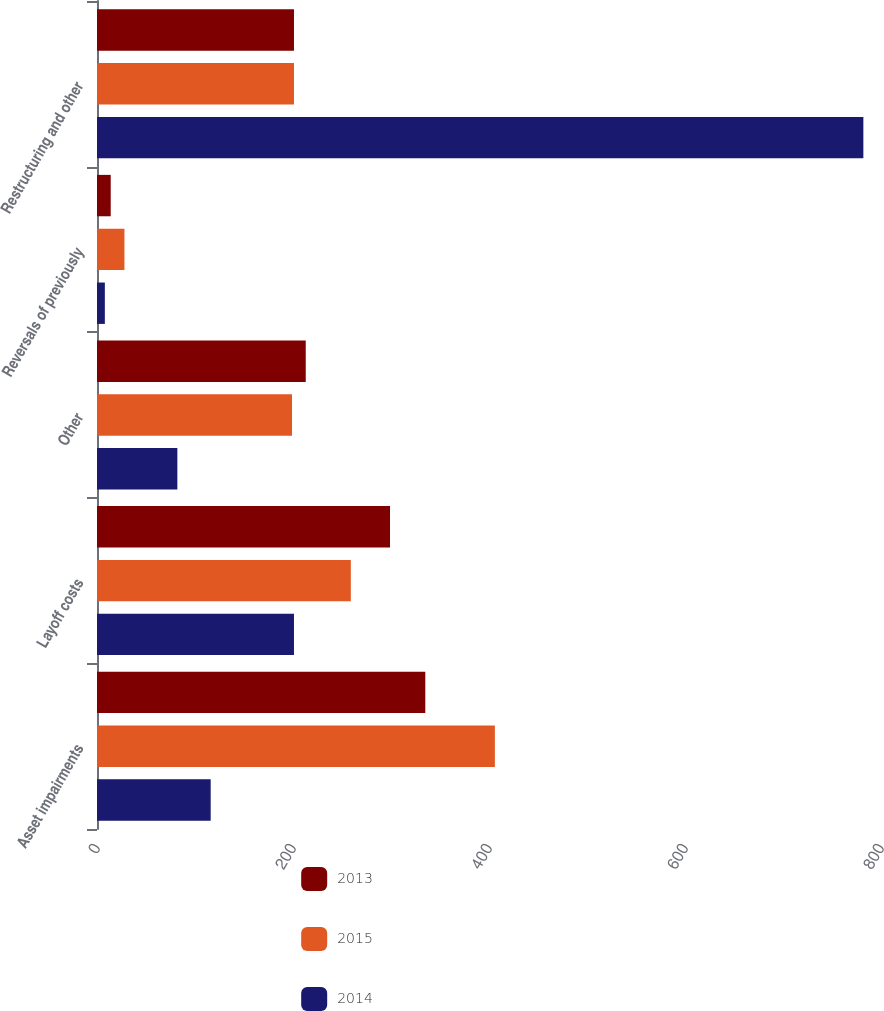Convert chart to OTSL. <chart><loc_0><loc_0><loc_500><loc_500><stacked_bar_chart><ecel><fcel>Asset impairments<fcel>Layoff costs<fcel>Other<fcel>Reversals of previously<fcel>Restructuring and other<nl><fcel>2013<fcel>335<fcel>299<fcel>213<fcel>14<fcel>201<nl><fcel>2015<fcel>406<fcel>259<fcel>199<fcel>28<fcel>201<nl><fcel>2014<fcel>116<fcel>201<fcel>82<fcel>8<fcel>782<nl></chart> 